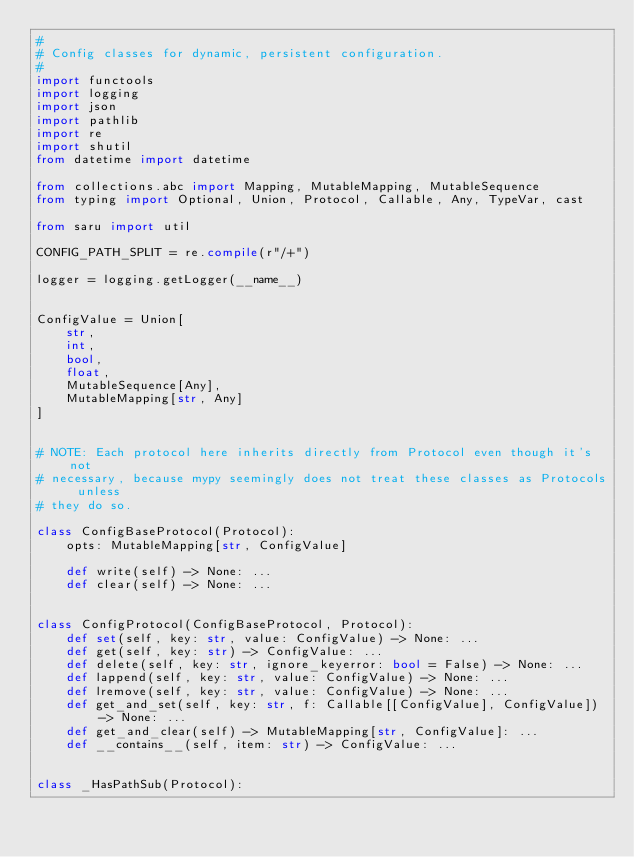<code> <loc_0><loc_0><loc_500><loc_500><_Python_>#
# Config classes for dynamic, persistent configuration.
#
import functools
import logging
import json
import pathlib
import re
import shutil
from datetime import datetime

from collections.abc import Mapping, MutableMapping, MutableSequence
from typing import Optional, Union, Protocol, Callable, Any, TypeVar, cast

from saru import util

CONFIG_PATH_SPLIT = re.compile(r"/+")

logger = logging.getLogger(__name__)


ConfigValue = Union[
    str,
    int,
    bool,
    float,
    MutableSequence[Any],
    MutableMapping[str, Any]
]


# NOTE: Each protocol here inherits directly from Protocol even though it's not
# necessary, because mypy seemingly does not treat these classes as Protocols unless
# they do so.

class ConfigBaseProtocol(Protocol):
    opts: MutableMapping[str, ConfigValue]

    def write(self) -> None: ...
    def clear(self) -> None: ...


class ConfigProtocol(ConfigBaseProtocol, Protocol):
    def set(self, key: str, value: ConfigValue) -> None: ...
    def get(self, key: str) -> ConfigValue: ...
    def delete(self, key: str, ignore_keyerror: bool = False) -> None: ...
    def lappend(self, key: str, value: ConfigValue) -> None: ...
    def lremove(self, key: str, value: ConfigValue) -> None: ...
    def get_and_set(self, key: str, f: Callable[[ConfigValue], ConfigValue]) -> None: ...
    def get_and_clear(self) -> MutableMapping[str, ConfigValue]: ...
    def __contains__(self, item: str) -> ConfigValue: ...


class _HasPathSub(Protocol):</code> 